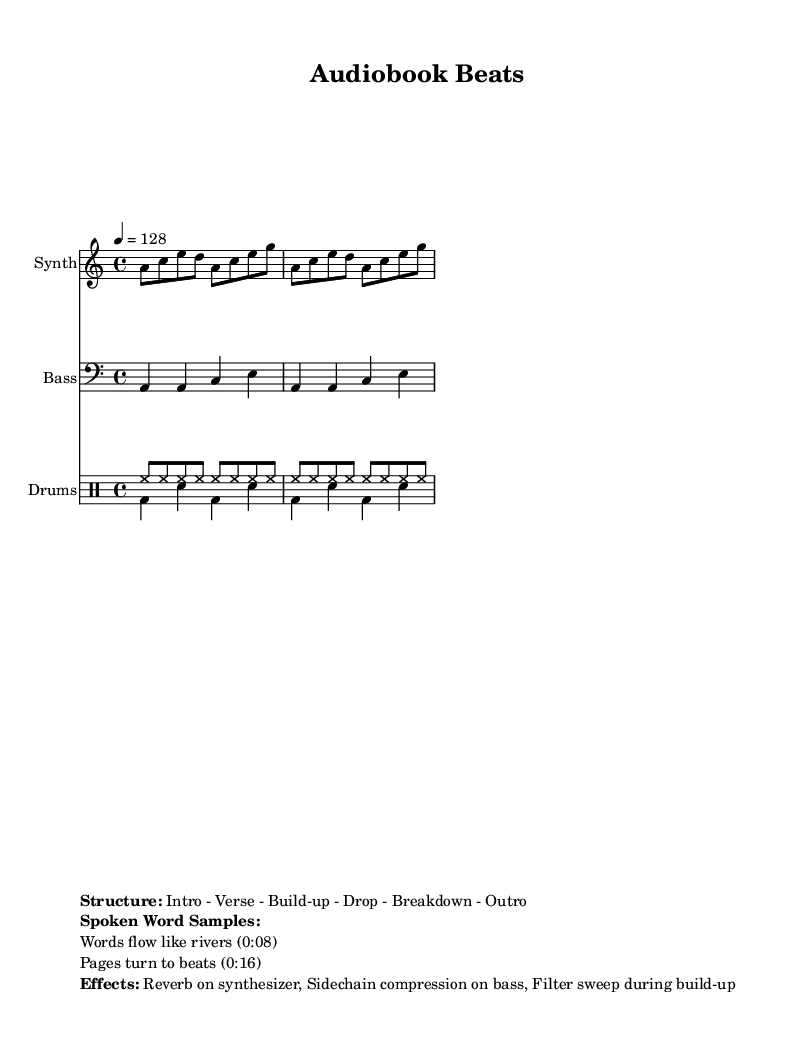What is the key signature of this music? The key signature at the beginning of the score indicates the key of A minor, which has no sharps or flats.
Answer: A minor What is the time signature of this music? The time signature shown in the music is 4/4, meaning there are four beats in each measure.
Answer: 4/4 What is the tempo of this piece? The tempo marking indicates a speed of 128 beats per minute, shown by '4 = 128' in the score.
Answer: 128 How many sections are specified in the structure? The structure section lists six parts, identified as Intro, Verse, Build-up, Drop, Breakdown, and Outro.
Answer: Six What happens to the synthesizer during the build-up? During the build-up, a filter sweep effect is applied to the synthesizer, enhancing the dynamic transition in the music.
Answer: Filter sweep How many spoken word samples are included in the score? Two spoken word samples are listed in the markup section of the score, detailing phrases and their timings.
Answer: Two What type of effect is applied to the bass? The bass in this piece utilizes sidechain compression, a common technique in house music to create a pumping sound.
Answer: Sidechain compression 